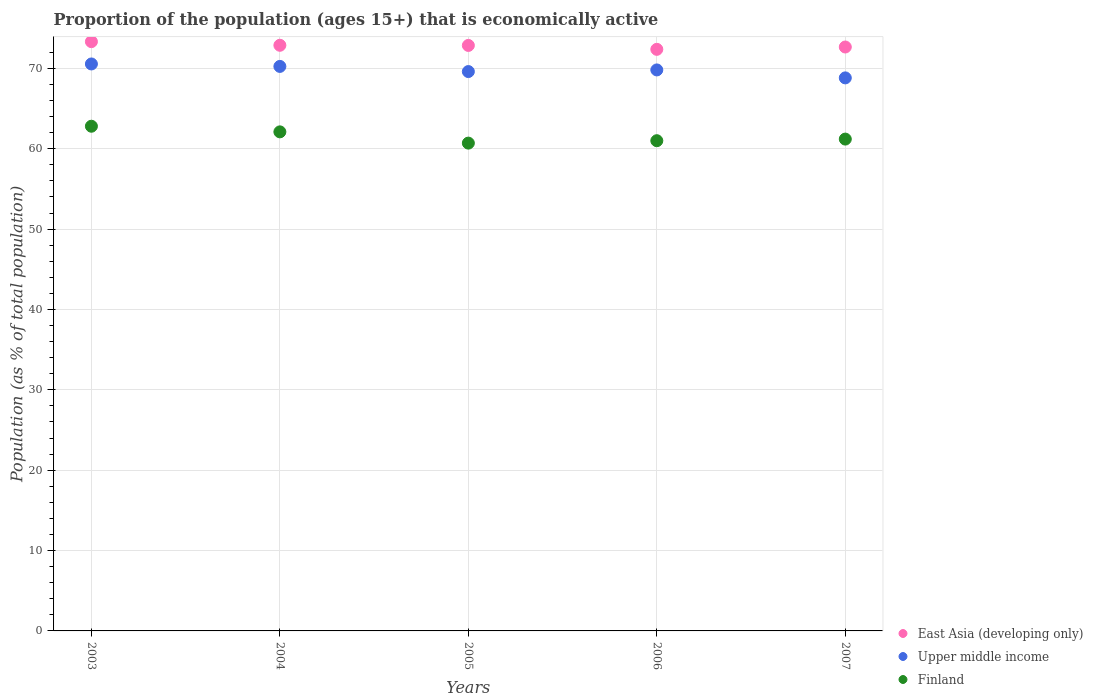Is the number of dotlines equal to the number of legend labels?
Offer a very short reply. Yes. What is the proportion of the population that is economically active in Upper middle income in 2006?
Your answer should be very brief. 69.81. Across all years, what is the maximum proportion of the population that is economically active in Upper middle income?
Make the answer very short. 70.55. Across all years, what is the minimum proportion of the population that is economically active in Upper middle income?
Your response must be concise. 68.82. In which year was the proportion of the population that is economically active in Finland minimum?
Provide a succinct answer. 2005. What is the total proportion of the population that is economically active in Upper middle income in the graph?
Offer a very short reply. 349.02. What is the difference between the proportion of the population that is economically active in Upper middle income in 2003 and that in 2004?
Provide a succinct answer. 0.31. What is the difference between the proportion of the population that is economically active in Upper middle income in 2003 and the proportion of the population that is economically active in Finland in 2005?
Make the answer very short. 9.85. What is the average proportion of the population that is economically active in Finland per year?
Offer a very short reply. 61.56. In the year 2004, what is the difference between the proportion of the population that is economically active in East Asia (developing only) and proportion of the population that is economically active in Upper middle income?
Offer a terse response. 2.63. What is the ratio of the proportion of the population that is economically active in East Asia (developing only) in 2003 to that in 2006?
Offer a very short reply. 1.01. What is the difference between the highest and the second highest proportion of the population that is economically active in Upper middle income?
Make the answer very short. 0.31. What is the difference between the highest and the lowest proportion of the population that is economically active in Finland?
Offer a terse response. 2.1. Is the sum of the proportion of the population that is economically active in Finland in 2005 and 2007 greater than the maximum proportion of the population that is economically active in East Asia (developing only) across all years?
Provide a succinct answer. Yes. Is it the case that in every year, the sum of the proportion of the population that is economically active in Upper middle income and proportion of the population that is economically active in Finland  is greater than the proportion of the population that is economically active in East Asia (developing only)?
Ensure brevity in your answer.  Yes. Does the proportion of the population that is economically active in Upper middle income monotonically increase over the years?
Your answer should be compact. No. Is the proportion of the population that is economically active in East Asia (developing only) strictly less than the proportion of the population that is economically active in Upper middle income over the years?
Your response must be concise. No. How many dotlines are there?
Offer a very short reply. 3. How many years are there in the graph?
Give a very brief answer. 5. How many legend labels are there?
Provide a short and direct response. 3. How are the legend labels stacked?
Ensure brevity in your answer.  Vertical. What is the title of the graph?
Offer a terse response. Proportion of the population (ages 15+) that is economically active. Does "France" appear as one of the legend labels in the graph?
Provide a short and direct response. No. What is the label or title of the X-axis?
Offer a very short reply. Years. What is the label or title of the Y-axis?
Offer a terse response. Population (as % of total population). What is the Population (as % of total population) in East Asia (developing only) in 2003?
Ensure brevity in your answer.  73.33. What is the Population (as % of total population) of Upper middle income in 2003?
Offer a very short reply. 70.55. What is the Population (as % of total population) of Finland in 2003?
Offer a terse response. 62.8. What is the Population (as % of total population) in East Asia (developing only) in 2004?
Make the answer very short. 72.87. What is the Population (as % of total population) in Upper middle income in 2004?
Keep it short and to the point. 70.24. What is the Population (as % of total population) in Finland in 2004?
Keep it short and to the point. 62.1. What is the Population (as % of total population) in East Asia (developing only) in 2005?
Ensure brevity in your answer.  72.85. What is the Population (as % of total population) in Upper middle income in 2005?
Provide a short and direct response. 69.6. What is the Population (as % of total population) of Finland in 2005?
Offer a terse response. 60.7. What is the Population (as % of total population) of East Asia (developing only) in 2006?
Ensure brevity in your answer.  72.37. What is the Population (as % of total population) in Upper middle income in 2006?
Make the answer very short. 69.81. What is the Population (as % of total population) of East Asia (developing only) in 2007?
Provide a succinct answer. 72.66. What is the Population (as % of total population) in Upper middle income in 2007?
Provide a succinct answer. 68.82. What is the Population (as % of total population) of Finland in 2007?
Your response must be concise. 61.2. Across all years, what is the maximum Population (as % of total population) in East Asia (developing only)?
Provide a short and direct response. 73.33. Across all years, what is the maximum Population (as % of total population) of Upper middle income?
Offer a terse response. 70.55. Across all years, what is the maximum Population (as % of total population) of Finland?
Provide a succinct answer. 62.8. Across all years, what is the minimum Population (as % of total population) in East Asia (developing only)?
Your answer should be compact. 72.37. Across all years, what is the minimum Population (as % of total population) of Upper middle income?
Ensure brevity in your answer.  68.82. Across all years, what is the minimum Population (as % of total population) of Finland?
Give a very brief answer. 60.7. What is the total Population (as % of total population) of East Asia (developing only) in the graph?
Offer a terse response. 364.08. What is the total Population (as % of total population) in Upper middle income in the graph?
Your answer should be very brief. 349.02. What is the total Population (as % of total population) in Finland in the graph?
Ensure brevity in your answer.  307.8. What is the difference between the Population (as % of total population) of East Asia (developing only) in 2003 and that in 2004?
Give a very brief answer. 0.45. What is the difference between the Population (as % of total population) of Upper middle income in 2003 and that in 2004?
Ensure brevity in your answer.  0.31. What is the difference between the Population (as % of total population) in Finland in 2003 and that in 2004?
Ensure brevity in your answer.  0.7. What is the difference between the Population (as % of total population) in East Asia (developing only) in 2003 and that in 2005?
Give a very brief answer. 0.47. What is the difference between the Population (as % of total population) of Upper middle income in 2003 and that in 2005?
Your answer should be compact. 0.95. What is the difference between the Population (as % of total population) in Finland in 2003 and that in 2005?
Your response must be concise. 2.1. What is the difference between the Population (as % of total population) in East Asia (developing only) in 2003 and that in 2006?
Give a very brief answer. 0.96. What is the difference between the Population (as % of total population) of Upper middle income in 2003 and that in 2006?
Offer a terse response. 0.74. What is the difference between the Population (as % of total population) of Finland in 2003 and that in 2006?
Keep it short and to the point. 1.8. What is the difference between the Population (as % of total population) in East Asia (developing only) in 2003 and that in 2007?
Your answer should be compact. 0.67. What is the difference between the Population (as % of total population) of Upper middle income in 2003 and that in 2007?
Offer a terse response. 1.73. What is the difference between the Population (as % of total population) in Finland in 2003 and that in 2007?
Ensure brevity in your answer.  1.6. What is the difference between the Population (as % of total population) in East Asia (developing only) in 2004 and that in 2005?
Give a very brief answer. 0.02. What is the difference between the Population (as % of total population) in Upper middle income in 2004 and that in 2005?
Offer a very short reply. 0.64. What is the difference between the Population (as % of total population) in Finland in 2004 and that in 2005?
Keep it short and to the point. 1.4. What is the difference between the Population (as % of total population) in East Asia (developing only) in 2004 and that in 2006?
Make the answer very short. 0.5. What is the difference between the Population (as % of total population) of Upper middle income in 2004 and that in 2006?
Provide a succinct answer. 0.44. What is the difference between the Population (as % of total population) in East Asia (developing only) in 2004 and that in 2007?
Ensure brevity in your answer.  0.21. What is the difference between the Population (as % of total population) of Upper middle income in 2004 and that in 2007?
Your answer should be compact. 1.43. What is the difference between the Population (as % of total population) in Finland in 2004 and that in 2007?
Offer a terse response. 0.9. What is the difference between the Population (as % of total population) of East Asia (developing only) in 2005 and that in 2006?
Give a very brief answer. 0.48. What is the difference between the Population (as % of total population) of Upper middle income in 2005 and that in 2006?
Your response must be concise. -0.2. What is the difference between the Population (as % of total population) of Finland in 2005 and that in 2006?
Your answer should be very brief. -0.3. What is the difference between the Population (as % of total population) in East Asia (developing only) in 2005 and that in 2007?
Keep it short and to the point. 0.2. What is the difference between the Population (as % of total population) of Upper middle income in 2005 and that in 2007?
Offer a very short reply. 0.79. What is the difference between the Population (as % of total population) of East Asia (developing only) in 2006 and that in 2007?
Keep it short and to the point. -0.29. What is the difference between the Population (as % of total population) of Upper middle income in 2006 and that in 2007?
Your answer should be compact. 0.99. What is the difference between the Population (as % of total population) in Finland in 2006 and that in 2007?
Your answer should be compact. -0.2. What is the difference between the Population (as % of total population) in East Asia (developing only) in 2003 and the Population (as % of total population) in Upper middle income in 2004?
Provide a short and direct response. 3.08. What is the difference between the Population (as % of total population) of East Asia (developing only) in 2003 and the Population (as % of total population) of Finland in 2004?
Provide a short and direct response. 11.23. What is the difference between the Population (as % of total population) of Upper middle income in 2003 and the Population (as % of total population) of Finland in 2004?
Keep it short and to the point. 8.45. What is the difference between the Population (as % of total population) in East Asia (developing only) in 2003 and the Population (as % of total population) in Upper middle income in 2005?
Provide a succinct answer. 3.72. What is the difference between the Population (as % of total population) in East Asia (developing only) in 2003 and the Population (as % of total population) in Finland in 2005?
Give a very brief answer. 12.63. What is the difference between the Population (as % of total population) of Upper middle income in 2003 and the Population (as % of total population) of Finland in 2005?
Offer a terse response. 9.85. What is the difference between the Population (as % of total population) of East Asia (developing only) in 2003 and the Population (as % of total population) of Upper middle income in 2006?
Provide a succinct answer. 3.52. What is the difference between the Population (as % of total population) in East Asia (developing only) in 2003 and the Population (as % of total population) in Finland in 2006?
Ensure brevity in your answer.  12.33. What is the difference between the Population (as % of total population) in Upper middle income in 2003 and the Population (as % of total population) in Finland in 2006?
Provide a succinct answer. 9.55. What is the difference between the Population (as % of total population) in East Asia (developing only) in 2003 and the Population (as % of total population) in Upper middle income in 2007?
Keep it short and to the point. 4.51. What is the difference between the Population (as % of total population) in East Asia (developing only) in 2003 and the Population (as % of total population) in Finland in 2007?
Your answer should be compact. 12.13. What is the difference between the Population (as % of total population) of Upper middle income in 2003 and the Population (as % of total population) of Finland in 2007?
Provide a short and direct response. 9.35. What is the difference between the Population (as % of total population) in East Asia (developing only) in 2004 and the Population (as % of total population) in Upper middle income in 2005?
Provide a short and direct response. 3.27. What is the difference between the Population (as % of total population) of East Asia (developing only) in 2004 and the Population (as % of total population) of Finland in 2005?
Offer a very short reply. 12.17. What is the difference between the Population (as % of total population) in Upper middle income in 2004 and the Population (as % of total population) in Finland in 2005?
Keep it short and to the point. 9.54. What is the difference between the Population (as % of total population) of East Asia (developing only) in 2004 and the Population (as % of total population) of Upper middle income in 2006?
Provide a short and direct response. 3.07. What is the difference between the Population (as % of total population) in East Asia (developing only) in 2004 and the Population (as % of total population) in Finland in 2006?
Provide a succinct answer. 11.87. What is the difference between the Population (as % of total population) of Upper middle income in 2004 and the Population (as % of total population) of Finland in 2006?
Make the answer very short. 9.24. What is the difference between the Population (as % of total population) in East Asia (developing only) in 2004 and the Population (as % of total population) in Upper middle income in 2007?
Provide a succinct answer. 4.06. What is the difference between the Population (as % of total population) of East Asia (developing only) in 2004 and the Population (as % of total population) of Finland in 2007?
Ensure brevity in your answer.  11.67. What is the difference between the Population (as % of total population) in Upper middle income in 2004 and the Population (as % of total population) in Finland in 2007?
Keep it short and to the point. 9.04. What is the difference between the Population (as % of total population) of East Asia (developing only) in 2005 and the Population (as % of total population) of Upper middle income in 2006?
Offer a terse response. 3.05. What is the difference between the Population (as % of total population) of East Asia (developing only) in 2005 and the Population (as % of total population) of Finland in 2006?
Provide a short and direct response. 11.85. What is the difference between the Population (as % of total population) in Upper middle income in 2005 and the Population (as % of total population) in Finland in 2006?
Provide a short and direct response. 8.6. What is the difference between the Population (as % of total population) in East Asia (developing only) in 2005 and the Population (as % of total population) in Upper middle income in 2007?
Provide a short and direct response. 4.04. What is the difference between the Population (as % of total population) in East Asia (developing only) in 2005 and the Population (as % of total population) in Finland in 2007?
Your answer should be very brief. 11.65. What is the difference between the Population (as % of total population) in Upper middle income in 2005 and the Population (as % of total population) in Finland in 2007?
Your answer should be very brief. 8.4. What is the difference between the Population (as % of total population) in East Asia (developing only) in 2006 and the Population (as % of total population) in Upper middle income in 2007?
Your answer should be very brief. 3.55. What is the difference between the Population (as % of total population) of East Asia (developing only) in 2006 and the Population (as % of total population) of Finland in 2007?
Provide a succinct answer. 11.17. What is the difference between the Population (as % of total population) in Upper middle income in 2006 and the Population (as % of total population) in Finland in 2007?
Offer a terse response. 8.61. What is the average Population (as % of total population) of East Asia (developing only) per year?
Keep it short and to the point. 72.82. What is the average Population (as % of total population) of Upper middle income per year?
Keep it short and to the point. 69.8. What is the average Population (as % of total population) of Finland per year?
Keep it short and to the point. 61.56. In the year 2003, what is the difference between the Population (as % of total population) in East Asia (developing only) and Population (as % of total population) in Upper middle income?
Your answer should be compact. 2.78. In the year 2003, what is the difference between the Population (as % of total population) in East Asia (developing only) and Population (as % of total population) in Finland?
Offer a terse response. 10.53. In the year 2003, what is the difference between the Population (as % of total population) in Upper middle income and Population (as % of total population) in Finland?
Your response must be concise. 7.75. In the year 2004, what is the difference between the Population (as % of total population) of East Asia (developing only) and Population (as % of total population) of Upper middle income?
Provide a succinct answer. 2.63. In the year 2004, what is the difference between the Population (as % of total population) of East Asia (developing only) and Population (as % of total population) of Finland?
Your response must be concise. 10.77. In the year 2004, what is the difference between the Population (as % of total population) of Upper middle income and Population (as % of total population) of Finland?
Give a very brief answer. 8.14. In the year 2005, what is the difference between the Population (as % of total population) in East Asia (developing only) and Population (as % of total population) in Upper middle income?
Ensure brevity in your answer.  3.25. In the year 2005, what is the difference between the Population (as % of total population) in East Asia (developing only) and Population (as % of total population) in Finland?
Make the answer very short. 12.15. In the year 2005, what is the difference between the Population (as % of total population) in Upper middle income and Population (as % of total population) in Finland?
Your response must be concise. 8.9. In the year 2006, what is the difference between the Population (as % of total population) of East Asia (developing only) and Population (as % of total population) of Upper middle income?
Offer a terse response. 2.56. In the year 2006, what is the difference between the Population (as % of total population) in East Asia (developing only) and Population (as % of total population) in Finland?
Give a very brief answer. 11.37. In the year 2006, what is the difference between the Population (as % of total population) in Upper middle income and Population (as % of total population) in Finland?
Ensure brevity in your answer.  8.81. In the year 2007, what is the difference between the Population (as % of total population) in East Asia (developing only) and Population (as % of total population) in Upper middle income?
Your answer should be very brief. 3.84. In the year 2007, what is the difference between the Population (as % of total population) in East Asia (developing only) and Population (as % of total population) in Finland?
Your answer should be compact. 11.46. In the year 2007, what is the difference between the Population (as % of total population) of Upper middle income and Population (as % of total population) of Finland?
Provide a short and direct response. 7.62. What is the ratio of the Population (as % of total population) in East Asia (developing only) in 2003 to that in 2004?
Offer a very short reply. 1.01. What is the ratio of the Population (as % of total population) in Finland in 2003 to that in 2004?
Ensure brevity in your answer.  1.01. What is the ratio of the Population (as % of total population) of East Asia (developing only) in 2003 to that in 2005?
Offer a very short reply. 1.01. What is the ratio of the Population (as % of total population) of Upper middle income in 2003 to that in 2005?
Your answer should be compact. 1.01. What is the ratio of the Population (as % of total population) in Finland in 2003 to that in 2005?
Provide a succinct answer. 1.03. What is the ratio of the Population (as % of total population) of East Asia (developing only) in 2003 to that in 2006?
Your answer should be compact. 1.01. What is the ratio of the Population (as % of total population) of Upper middle income in 2003 to that in 2006?
Your answer should be very brief. 1.01. What is the ratio of the Population (as % of total population) in Finland in 2003 to that in 2006?
Make the answer very short. 1.03. What is the ratio of the Population (as % of total population) of East Asia (developing only) in 2003 to that in 2007?
Ensure brevity in your answer.  1.01. What is the ratio of the Population (as % of total population) in Upper middle income in 2003 to that in 2007?
Ensure brevity in your answer.  1.03. What is the ratio of the Population (as % of total population) of Finland in 2003 to that in 2007?
Your answer should be compact. 1.03. What is the ratio of the Population (as % of total population) of Upper middle income in 2004 to that in 2005?
Ensure brevity in your answer.  1.01. What is the ratio of the Population (as % of total population) in Finland in 2004 to that in 2005?
Your answer should be very brief. 1.02. What is the ratio of the Population (as % of total population) of East Asia (developing only) in 2004 to that in 2006?
Provide a succinct answer. 1.01. What is the ratio of the Population (as % of total population) of East Asia (developing only) in 2004 to that in 2007?
Keep it short and to the point. 1. What is the ratio of the Population (as % of total population) of Upper middle income in 2004 to that in 2007?
Keep it short and to the point. 1.02. What is the ratio of the Population (as % of total population) of Finland in 2004 to that in 2007?
Your response must be concise. 1.01. What is the ratio of the Population (as % of total population) of East Asia (developing only) in 2005 to that in 2006?
Your response must be concise. 1.01. What is the ratio of the Population (as % of total population) in Upper middle income in 2005 to that in 2007?
Provide a short and direct response. 1.01. What is the ratio of the Population (as % of total population) in East Asia (developing only) in 2006 to that in 2007?
Your answer should be very brief. 1. What is the ratio of the Population (as % of total population) in Upper middle income in 2006 to that in 2007?
Provide a short and direct response. 1.01. What is the difference between the highest and the second highest Population (as % of total population) of East Asia (developing only)?
Keep it short and to the point. 0.45. What is the difference between the highest and the second highest Population (as % of total population) of Upper middle income?
Offer a terse response. 0.31. What is the difference between the highest and the lowest Population (as % of total population) in East Asia (developing only)?
Ensure brevity in your answer.  0.96. What is the difference between the highest and the lowest Population (as % of total population) in Upper middle income?
Make the answer very short. 1.73. What is the difference between the highest and the lowest Population (as % of total population) in Finland?
Your answer should be very brief. 2.1. 